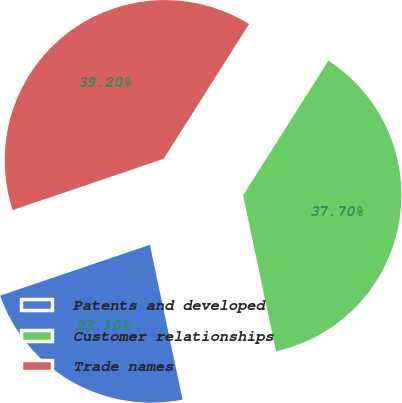Convert chart to OTSL. <chart><loc_0><loc_0><loc_500><loc_500><pie_chart><fcel>Patents and developed<fcel>Customer relationships<fcel>Trade names<nl><fcel>23.1%<fcel>37.7%<fcel>39.2%<nl></chart> 